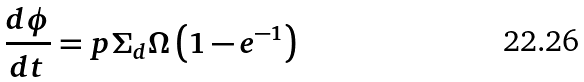<formula> <loc_0><loc_0><loc_500><loc_500>\frac { d \phi } { d t } = p \Sigma _ { d } \Omega \left ( 1 - e ^ { - 1 } \right )</formula> 